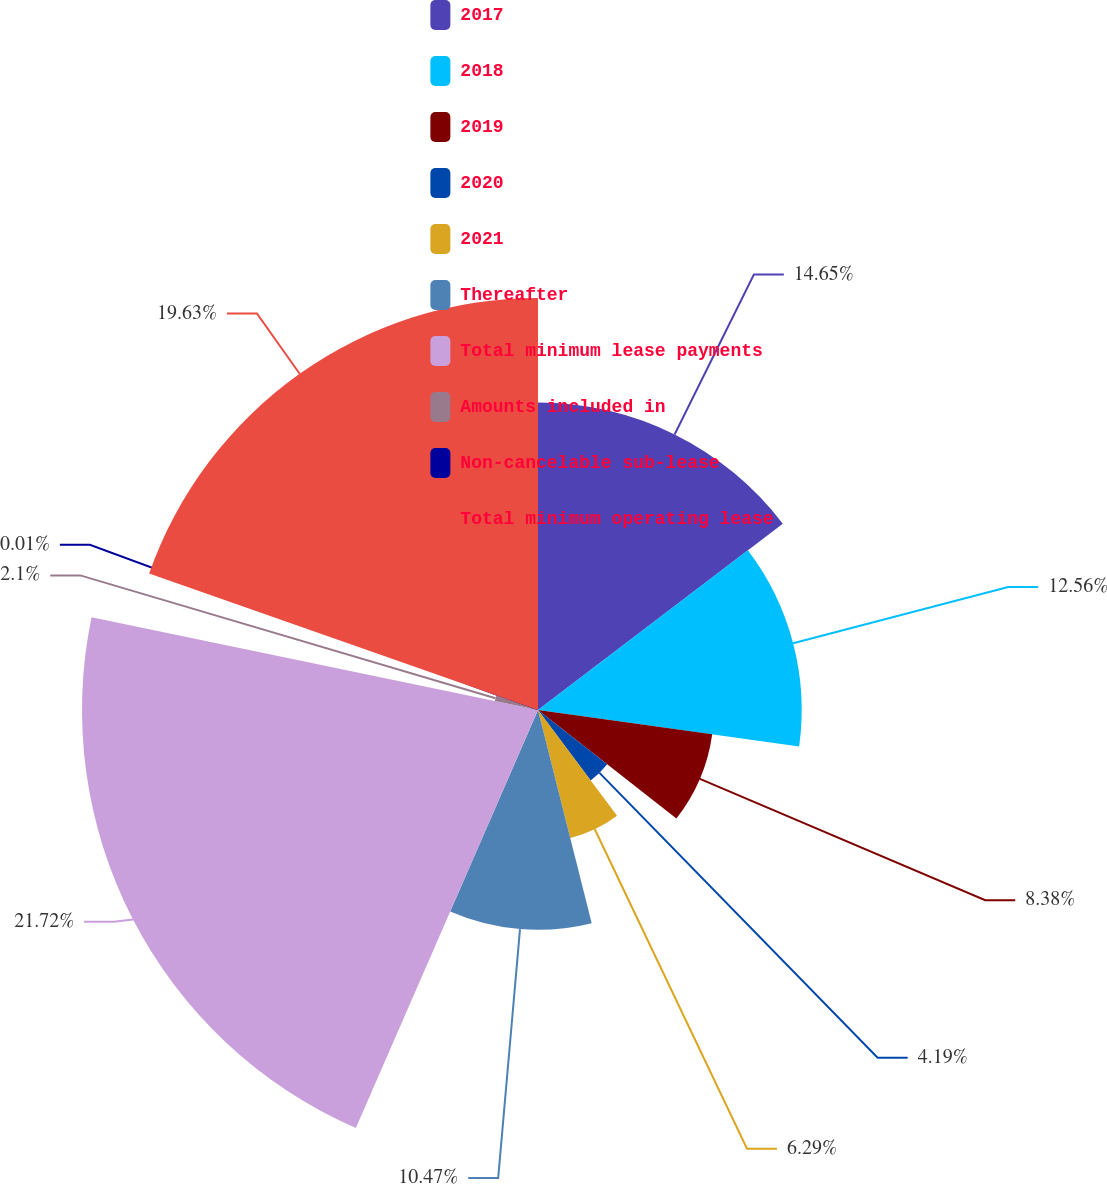Convert chart to OTSL. <chart><loc_0><loc_0><loc_500><loc_500><pie_chart><fcel>2017<fcel>2018<fcel>2019<fcel>2020<fcel>2021<fcel>Thereafter<fcel>Total minimum lease payments<fcel>Amounts included in<fcel>Non-cancelable sub-lease<fcel>Total minimum operating lease<nl><fcel>14.65%<fcel>12.56%<fcel>8.38%<fcel>4.19%<fcel>6.29%<fcel>10.47%<fcel>21.72%<fcel>2.1%<fcel>0.01%<fcel>19.63%<nl></chart> 